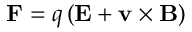<formula> <loc_0><loc_0><loc_500><loc_500>F = q \left ( E + v \times B \right )</formula> 